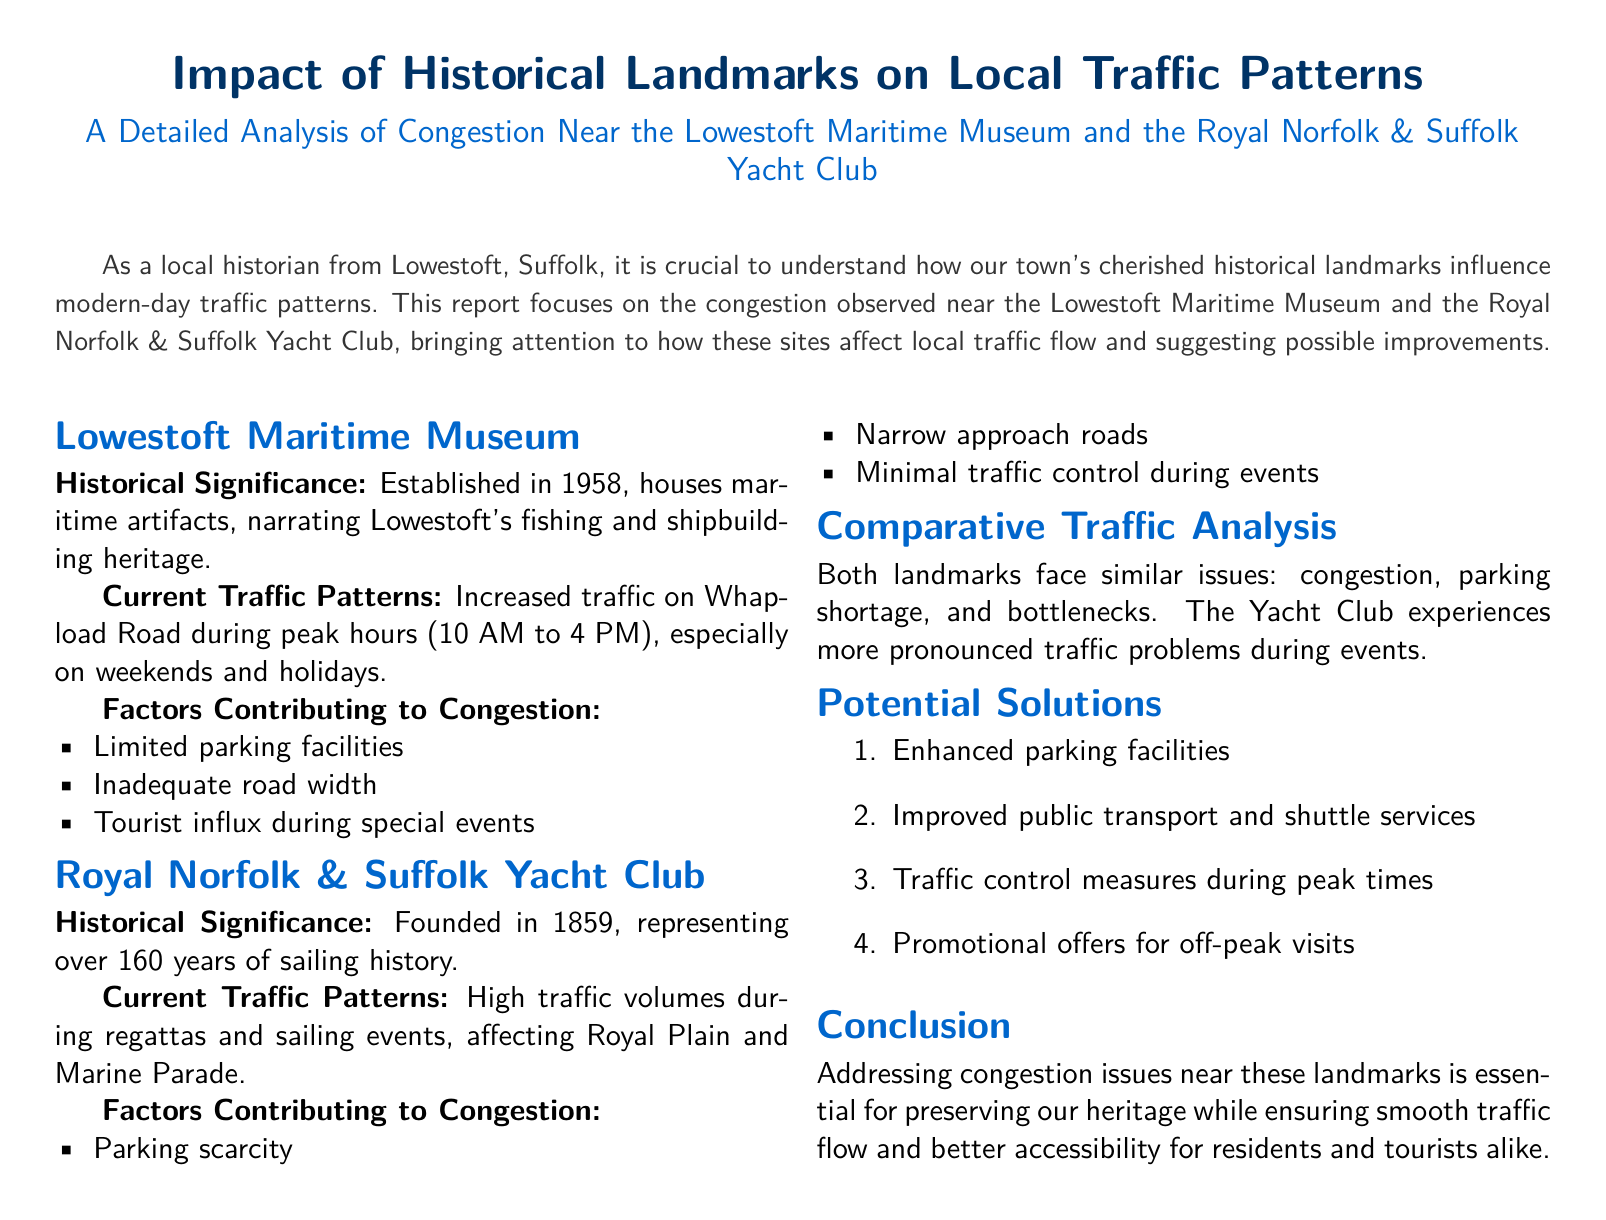What year was the Lowestoft Maritime Museum established? The document states that the Lowestoft Maritime Museum was established in 1958.
Answer: 1958 What are the peak traffic hours near the Lowestoft Maritime Museum? The report indicates increased traffic on Whapload Road during peak hours from 10 AM to 4 PM.
Answer: 10 AM to 4 PM When was the Royal Norfolk & Suffolk Yacht Club founded? The document specifies that the Royal Norfolk & Suffolk Yacht Club was founded in 1859.
Answer: 1859 What major events contribute to high traffic at the Yacht Club? The report identifies regattas and sailing events as significant contributors to high traffic volumes at the Yacht Club.
Answer: Regattas and sailing events What is one factor contributing to congestion at the Lowestoft Maritime Museum? The document lists limited parking facilities as a contributing factor to congestion at the Lowestoft Maritime Museum.
Answer: Limited parking facilities How long has the Royal Norfolk & Suffolk Yacht Club been in existence? The document mentions that the Royal Norfolk & Suffolk Yacht Club represents over 160 years of sailing history.
Answer: Over 160 years What is one suggested solution for congestion mentioned in the report? The document proposes enhanced parking facilities as one of the potential solutions to congestion.
Answer: Enhanced parking facilities Which road faces traffic issues during events at the Yacht Club? The report states that Royal Plain and Marine Parade experience high traffic volumes during events at the Yacht Club.
Answer: Royal Plain and Marine Parade 